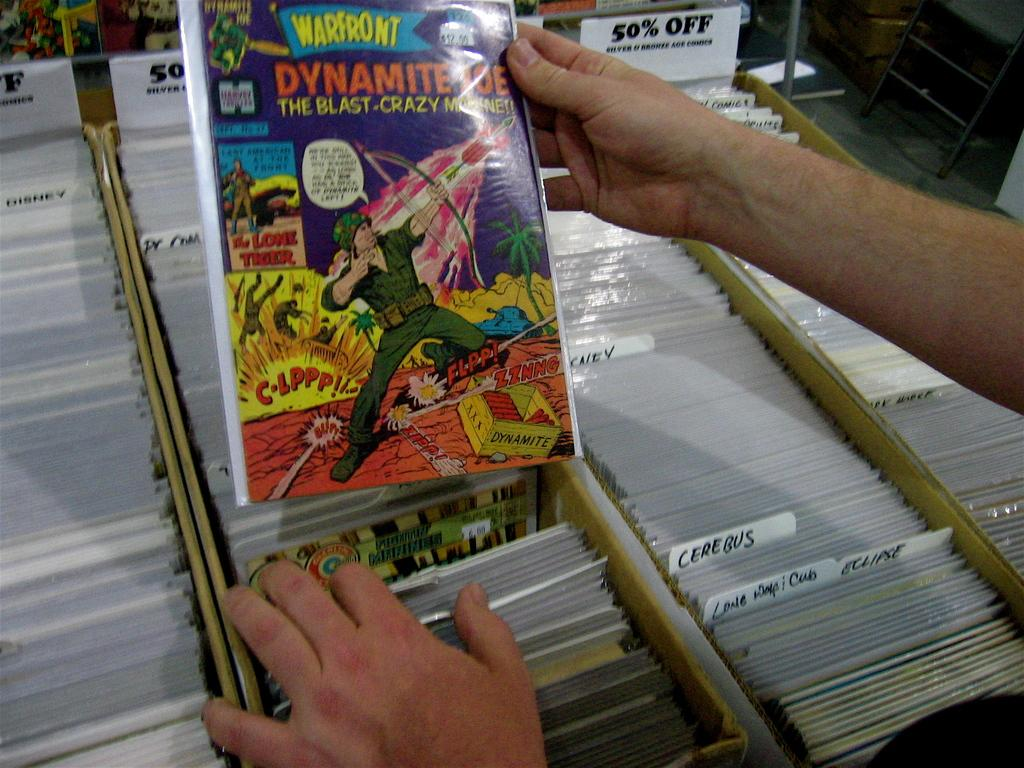<image>
Summarize the visual content of the image. Someone holds up a Dynamite Joe comic book. 